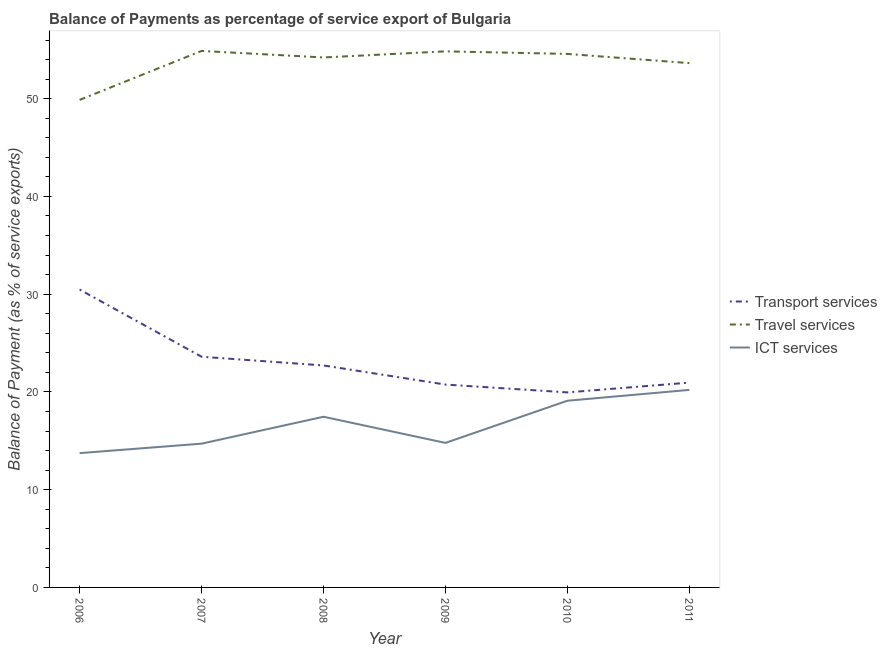Is the number of lines equal to the number of legend labels?
Offer a terse response. Yes. What is the balance of payment of ict services in 2009?
Offer a very short reply. 14.78. Across all years, what is the maximum balance of payment of travel services?
Offer a very short reply. 54.88. Across all years, what is the minimum balance of payment of travel services?
Ensure brevity in your answer.  49.87. In which year was the balance of payment of transport services minimum?
Your response must be concise. 2010. What is the total balance of payment of ict services in the graph?
Provide a succinct answer. 100. What is the difference between the balance of payment of ict services in 2008 and that in 2010?
Your answer should be compact. -1.64. What is the difference between the balance of payment of travel services in 2010 and the balance of payment of transport services in 2011?
Your answer should be compact. 33.62. What is the average balance of payment of ict services per year?
Offer a terse response. 16.67. In the year 2006, what is the difference between the balance of payment of travel services and balance of payment of transport services?
Offer a terse response. 19.4. In how many years, is the balance of payment of travel services greater than 20 %?
Your answer should be very brief. 6. What is the ratio of the balance of payment of transport services in 2007 to that in 2010?
Offer a terse response. 1.18. Is the difference between the balance of payment of transport services in 2006 and 2007 greater than the difference between the balance of payment of travel services in 2006 and 2007?
Your response must be concise. Yes. What is the difference between the highest and the second highest balance of payment of travel services?
Ensure brevity in your answer.  0.04. What is the difference between the highest and the lowest balance of payment of transport services?
Ensure brevity in your answer.  10.52. Does the balance of payment of transport services monotonically increase over the years?
Give a very brief answer. No. Is the balance of payment of travel services strictly less than the balance of payment of ict services over the years?
Your answer should be compact. No. How many lines are there?
Provide a short and direct response. 3. What is the difference between two consecutive major ticks on the Y-axis?
Keep it short and to the point. 10. Are the values on the major ticks of Y-axis written in scientific E-notation?
Your answer should be compact. No. How many legend labels are there?
Offer a terse response. 3. What is the title of the graph?
Your answer should be very brief. Balance of Payments as percentage of service export of Bulgaria. Does "Transport" appear as one of the legend labels in the graph?
Offer a terse response. No. What is the label or title of the X-axis?
Your response must be concise. Year. What is the label or title of the Y-axis?
Offer a terse response. Balance of Payment (as % of service exports). What is the Balance of Payment (as % of service exports) of Transport services in 2006?
Make the answer very short. 30.47. What is the Balance of Payment (as % of service exports) of Travel services in 2006?
Your answer should be very brief. 49.87. What is the Balance of Payment (as % of service exports) in ICT services in 2006?
Provide a succinct answer. 13.74. What is the Balance of Payment (as % of service exports) in Transport services in 2007?
Keep it short and to the point. 23.6. What is the Balance of Payment (as % of service exports) of Travel services in 2007?
Offer a very short reply. 54.88. What is the Balance of Payment (as % of service exports) of ICT services in 2007?
Offer a very short reply. 14.71. What is the Balance of Payment (as % of service exports) in Transport services in 2008?
Provide a succinct answer. 22.71. What is the Balance of Payment (as % of service exports) of Travel services in 2008?
Provide a succinct answer. 54.22. What is the Balance of Payment (as % of service exports) of ICT services in 2008?
Offer a very short reply. 17.46. What is the Balance of Payment (as % of service exports) in Transport services in 2009?
Make the answer very short. 20.75. What is the Balance of Payment (as % of service exports) in Travel services in 2009?
Keep it short and to the point. 54.84. What is the Balance of Payment (as % of service exports) in ICT services in 2009?
Provide a short and direct response. 14.78. What is the Balance of Payment (as % of service exports) in Transport services in 2010?
Provide a succinct answer. 19.95. What is the Balance of Payment (as % of service exports) of Travel services in 2010?
Keep it short and to the point. 54.58. What is the Balance of Payment (as % of service exports) in ICT services in 2010?
Your answer should be very brief. 19.1. What is the Balance of Payment (as % of service exports) of Transport services in 2011?
Offer a terse response. 20.95. What is the Balance of Payment (as % of service exports) of Travel services in 2011?
Provide a short and direct response. 53.64. What is the Balance of Payment (as % of service exports) in ICT services in 2011?
Offer a very short reply. 20.21. Across all years, what is the maximum Balance of Payment (as % of service exports) in Transport services?
Make the answer very short. 30.47. Across all years, what is the maximum Balance of Payment (as % of service exports) of Travel services?
Provide a short and direct response. 54.88. Across all years, what is the maximum Balance of Payment (as % of service exports) of ICT services?
Provide a succinct answer. 20.21. Across all years, what is the minimum Balance of Payment (as % of service exports) in Transport services?
Make the answer very short. 19.95. Across all years, what is the minimum Balance of Payment (as % of service exports) of Travel services?
Your answer should be very brief. 49.87. Across all years, what is the minimum Balance of Payment (as % of service exports) in ICT services?
Your answer should be very brief. 13.74. What is the total Balance of Payment (as % of service exports) in Transport services in the graph?
Give a very brief answer. 138.44. What is the total Balance of Payment (as % of service exports) in Travel services in the graph?
Your answer should be very brief. 322.03. What is the total Balance of Payment (as % of service exports) in ICT services in the graph?
Provide a succinct answer. 100. What is the difference between the Balance of Payment (as % of service exports) in Transport services in 2006 and that in 2007?
Your answer should be compact. 6.87. What is the difference between the Balance of Payment (as % of service exports) in Travel services in 2006 and that in 2007?
Your answer should be very brief. -5.01. What is the difference between the Balance of Payment (as % of service exports) in ICT services in 2006 and that in 2007?
Ensure brevity in your answer.  -0.97. What is the difference between the Balance of Payment (as % of service exports) in Transport services in 2006 and that in 2008?
Your answer should be very brief. 7.77. What is the difference between the Balance of Payment (as % of service exports) of Travel services in 2006 and that in 2008?
Make the answer very short. -4.34. What is the difference between the Balance of Payment (as % of service exports) of ICT services in 2006 and that in 2008?
Provide a succinct answer. -3.72. What is the difference between the Balance of Payment (as % of service exports) in Transport services in 2006 and that in 2009?
Give a very brief answer. 9.72. What is the difference between the Balance of Payment (as % of service exports) of Travel services in 2006 and that in 2009?
Your response must be concise. -4.97. What is the difference between the Balance of Payment (as % of service exports) of ICT services in 2006 and that in 2009?
Provide a succinct answer. -1.05. What is the difference between the Balance of Payment (as % of service exports) in Transport services in 2006 and that in 2010?
Offer a terse response. 10.52. What is the difference between the Balance of Payment (as % of service exports) in Travel services in 2006 and that in 2010?
Your answer should be compact. -4.7. What is the difference between the Balance of Payment (as % of service exports) in ICT services in 2006 and that in 2010?
Provide a succinct answer. -5.36. What is the difference between the Balance of Payment (as % of service exports) in Transport services in 2006 and that in 2011?
Offer a terse response. 9.52. What is the difference between the Balance of Payment (as % of service exports) of Travel services in 2006 and that in 2011?
Your response must be concise. -3.76. What is the difference between the Balance of Payment (as % of service exports) in ICT services in 2006 and that in 2011?
Offer a terse response. -6.47. What is the difference between the Balance of Payment (as % of service exports) of Transport services in 2007 and that in 2008?
Provide a succinct answer. 0.89. What is the difference between the Balance of Payment (as % of service exports) of Travel services in 2007 and that in 2008?
Provide a succinct answer. 0.67. What is the difference between the Balance of Payment (as % of service exports) in ICT services in 2007 and that in 2008?
Keep it short and to the point. -2.75. What is the difference between the Balance of Payment (as % of service exports) in Transport services in 2007 and that in 2009?
Provide a short and direct response. 2.85. What is the difference between the Balance of Payment (as % of service exports) in Travel services in 2007 and that in 2009?
Your answer should be compact. 0.04. What is the difference between the Balance of Payment (as % of service exports) in ICT services in 2007 and that in 2009?
Your answer should be very brief. -0.08. What is the difference between the Balance of Payment (as % of service exports) in Transport services in 2007 and that in 2010?
Your response must be concise. 3.65. What is the difference between the Balance of Payment (as % of service exports) of Travel services in 2007 and that in 2010?
Your answer should be compact. 0.31. What is the difference between the Balance of Payment (as % of service exports) of ICT services in 2007 and that in 2010?
Ensure brevity in your answer.  -4.39. What is the difference between the Balance of Payment (as % of service exports) of Transport services in 2007 and that in 2011?
Provide a succinct answer. 2.65. What is the difference between the Balance of Payment (as % of service exports) of Travel services in 2007 and that in 2011?
Provide a succinct answer. 1.25. What is the difference between the Balance of Payment (as % of service exports) in ICT services in 2007 and that in 2011?
Your response must be concise. -5.5. What is the difference between the Balance of Payment (as % of service exports) of Transport services in 2008 and that in 2009?
Provide a succinct answer. 1.96. What is the difference between the Balance of Payment (as % of service exports) of Travel services in 2008 and that in 2009?
Your answer should be very brief. -0.62. What is the difference between the Balance of Payment (as % of service exports) in ICT services in 2008 and that in 2009?
Your answer should be very brief. 2.67. What is the difference between the Balance of Payment (as % of service exports) of Transport services in 2008 and that in 2010?
Keep it short and to the point. 2.76. What is the difference between the Balance of Payment (as % of service exports) of Travel services in 2008 and that in 2010?
Give a very brief answer. -0.36. What is the difference between the Balance of Payment (as % of service exports) of ICT services in 2008 and that in 2010?
Provide a short and direct response. -1.64. What is the difference between the Balance of Payment (as % of service exports) in Transport services in 2008 and that in 2011?
Offer a very short reply. 1.75. What is the difference between the Balance of Payment (as % of service exports) of Travel services in 2008 and that in 2011?
Provide a short and direct response. 0.58. What is the difference between the Balance of Payment (as % of service exports) in ICT services in 2008 and that in 2011?
Your response must be concise. -2.75. What is the difference between the Balance of Payment (as % of service exports) in Transport services in 2009 and that in 2010?
Keep it short and to the point. 0.8. What is the difference between the Balance of Payment (as % of service exports) in Travel services in 2009 and that in 2010?
Your response must be concise. 0.26. What is the difference between the Balance of Payment (as % of service exports) in ICT services in 2009 and that in 2010?
Your response must be concise. -4.31. What is the difference between the Balance of Payment (as % of service exports) of Transport services in 2009 and that in 2011?
Ensure brevity in your answer.  -0.2. What is the difference between the Balance of Payment (as % of service exports) of Travel services in 2009 and that in 2011?
Provide a short and direct response. 1.2. What is the difference between the Balance of Payment (as % of service exports) of ICT services in 2009 and that in 2011?
Offer a very short reply. -5.42. What is the difference between the Balance of Payment (as % of service exports) of Transport services in 2010 and that in 2011?
Give a very brief answer. -1. What is the difference between the Balance of Payment (as % of service exports) of Travel services in 2010 and that in 2011?
Give a very brief answer. 0.94. What is the difference between the Balance of Payment (as % of service exports) in ICT services in 2010 and that in 2011?
Provide a succinct answer. -1.11. What is the difference between the Balance of Payment (as % of service exports) of Transport services in 2006 and the Balance of Payment (as % of service exports) of Travel services in 2007?
Keep it short and to the point. -24.41. What is the difference between the Balance of Payment (as % of service exports) in Transport services in 2006 and the Balance of Payment (as % of service exports) in ICT services in 2007?
Offer a very short reply. 15.77. What is the difference between the Balance of Payment (as % of service exports) in Travel services in 2006 and the Balance of Payment (as % of service exports) in ICT services in 2007?
Keep it short and to the point. 35.17. What is the difference between the Balance of Payment (as % of service exports) of Transport services in 2006 and the Balance of Payment (as % of service exports) of Travel services in 2008?
Provide a short and direct response. -23.74. What is the difference between the Balance of Payment (as % of service exports) of Transport services in 2006 and the Balance of Payment (as % of service exports) of ICT services in 2008?
Ensure brevity in your answer.  13.01. What is the difference between the Balance of Payment (as % of service exports) of Travel services in 2006 and the Balance of Payment (as % of service exports) of ICT services in 2008?
Provide a short and direct response. 32.41. What is the difference between the Balance of Payment (as % of service exports) of Transport services in 2006 and the Balance of Payment (as % of service exports) of Travel services in 2009?
Your answer should be very brief. -24.37. What is the difference between the Balance of Payment (as % of service exports) of Transport services in 2006 and the Balance of Payment (as % of service exports) of ICT services in 2009?
Keep it short and to the point. 15.69. What is the difference between the Balance of Payment (as % of service exports) in Travel services in 2006 and the Balance of Payment (as % of service exports) in ICT services in 2009?
Provide a short and direct response. 35.09. What is the difference between the Balance of Payment (as % of service exports) of Transport services in 2006 and the Balance of Payment (as % of service exports) of Travel services in 2010?
Make the answer very short. -24.1. What is the difference between the Balance of Payment (as % of service exports) of Transport services in 2006 and the Balance of Payment (as % of service exports) of ICT services in 2010?
Make the answer very short. 11.37. What is the difference between the Balance of Payment (as % of service exports) of Travel services in 2006 and the Balance of Payment (as % of service exports) of ICT services in 2010?
Your response must be concise. 30.77. What is the difference between the Balance of Payment (as % of service exports) in Transport services in 2006 and the Balance of Payment (as % of service exports) in Travel services in 2011?
Your answer should be very brief. -23.16. What is the difference between the Balance of Payment (as % of service exports) in Transport services in 2006 and the Balance of Payment (as % of service exports) in ICT services in 2011?
Your response must be concise. 10.27. What is the difference between the Balance of Payment (as % of service exports) in Travel services in 2006 and the Balance of Payment (as % of service exports) in ICT services in 2011?
Offer a very short reply. 29.67. What is the difference between the Balance of Payment (as % of service exports) in Transport services in 2007 and the Balance of Payment (as % of service exports) in Travel services in 2008?
Offer a terse response. -30.62. What is the difference between the Balance of Payment (as % of service exports) of Transport services in 2007 and the Balance of Payment (as % of service exports) of ICT services in 2008?
Give a very brief answer. 6.14. What is the difference between the Balance of Payment (as % of service exports) in Travel services in 2007 and the Balance of Payment (as % of service exports) in ICT services in 2008?
Your answer should be compact. 37.42. What is the difference between the Balance of Payment (as % of service exports) in Transport services in 2007 and the Balance of Payment (as % of service exports) in Travel services in 2009?
Keep it short and to the point. -31.24. What is the difference between the Balance of Payment (as % of service exports) in Transport services in 2007 and the Balance of Payment (as % of service exports) in ICT services in 2009?
Your response must be concise. 8.81. What is the difference between the Balance of Payment (as % of service exports) in Travel services in 2007 and the Balance of Payment (as % of service exports) in ICT services in 2009?
Provide a succinct answer. 40.1. What is the difference between the Balance of Payment (as % of service exports) in Transport services in 2007 and the Balance of Payment (as % of service exports) in Travel services in 2010?
Keep it short and to the point. -30.98. What is the difference between the Balance of Payment (as % of service exports) of Transport services in 2007 and the Balance of Payment (as % of service exports) of ICT services in 2010?
Give a very brief answer. 4.5. What is the difference between the Balance of Payment (as % of service exports) of Travel services in 2007 and the Balance of Payment (as % of service exports) of ICT services in 2010?
Ensure brevity in your answer.  35.78. What is the difference between the Balance of Payment (as % of service exports) of Transport services in 2007 and the Balance of Payment (as % of service exports) of Travel services in 2011?
Give a very brief answer. -30.04. What is the difference between the Balance of Payment (as % of service exports) of Transport services in 2007 and the Balance of Payment (as % of service exports) of ICT services in 2011?
Offer a terse response. 3.39. What is the difference between the Balance of Payment (as % of service exports) in Travel services in 2007 and the Balance of Payment (as % of service exports) in ICT services in 2011?
Provide a short and direct response. 34.67. What is the difference between the Balance of Payment (as % of service exports) of Transport services in 2008 and the Balance of Payment (as % of service exports) of Travel services in 2009?
Make the answer very short. -32.13. What is the difference between the Balance of Payment (as % of service exports) in Transport services in 2008 and the Balance of Payment (as % of service exports) in ICT services in 2009?
Provide a short and direct response. 7.92. What is the difference between the Balance of Payment (as % of service exports) of Travel services in 2008 and the Balance of Payment (as % of service exports) of ICT services in 2009?
Your answer should be compact. 39.43. What is the difference between the Balance of Payment (as % of service exports) in Transport services in 2008 and the Balance of Payment (as % of service exports) in Travel services in 2010?
Keep it short and to the point. -31.87. What is the difference between the Balance of Payment (as % of service exports) of Transport services in 2008 and the Balance of Payment (as % of service exports) of ICT services in 2010?
Make the answer very short. 3.61. What is the difference between the Balance of Payment (as % of service exports) of Travel services in 2008 and the Balance of Payment (as % of service exports) of ICT services in 2010?
Offer a terse response. 35.12. What is the difference between the Balance of Payment (as % of service exports) in Transport services in 2008 and the Balance of Payment (as % of service exports) in Travel services in 2011?
Ensure brevity in your answer.  -30.93. What is the difference between the Balance of Payment (as % of service exports) in Transport services in 2008 and the Balance of Payment (as % of service exports) in ICT services in 2011?
Your response must be concise. 2.5. What is the difference between the Balance of Payment (as % of service exports) in Travel services in 2008 and the Balance of Payment (as % of service exports) in ICT services in 2011?
Make the answer very short. 34.01. What is the difference between the Balance of Payment (as % of service exports) of Transport services in 2009 and the Balance of Payment (as % of service exports) of Travel services in 2010?
Keep it short and to the point. -33.82. What is the difference between the Balance of Payment (as % of service exports) in Transport services in 2009 and the Balance of Payment (as % of service exports) in ICT services in 2010?
Give a very brief answer. 1.65. What is the difference between the Balance of Payment (as % of service exports) in Travel services in 2009 and the Balance of Payment (as % of service exports) in ICT services in 2010?
Your response must be concise. 35.74. What is the difference between the Balance of Payment (as % of service exports) in Transport services in 2009 and the Balance of Payment (as % of service exports) in Travel services in 2011?
Your answer should be compact. -32.88. What is the difference between the Balance of Payment (as % of service exports) of Transport services in 2009 and the Balance of Payment (as % of service exports) of ICT services in 2011?
Keep it short and to the point. 0.54. What is the difference between the Balance of Payment (as % of service exports) of Travel services in 2009 and the Balance of Payment (as % of service exports) of ICT services in 2011?
Offer a very short reply. 34.63. What is the difference between the Balance of Payment (as % of service exports) in Transport services in 2010 and the Balance of Payment (as % of service exports) in Travel services in 2011?
Your answer should be compact. -33.69. What is the difference between the Balance of Payment (as % of service exports) of Transport services in 2010 and the Balance of Payment (as % of service exports) of ICT services in 2011?
Your answer should be very brief. -0.26. What is the difference between the Balance of Payment (as % of service exports) in Travel services in 2010 and the Balance of Payment (as % of service exports) in ICT services in 2011?
Give a very brief answer. 34.37. What is the average Balance of Payment (as % of service exports) of Transport services per year?
Provide a succinct answer. 23.07. What is the average Balance of Payment (as % of service exports) in Travel services per year?
Your response must be concise. 53.67. What is the average Balance of Payment (as % of service exports) of ICT services per year?
Give a very brief answer. 16.67. In the year 2006, what is the difference between the Balance of Payment (as % of service exports) in Transport services and Balance of Payment (as % of service exports) in Travel services?
Ensure brevity in your answer.  -19.4. In the year 2006, what is the difference between the Balance of Payment (as % of service exports) in Transport services and Balance of Payment (as % of service exports) in ICT services?
Provide a succinct answer. 16.73. In the year 2006, what is the difference between the Balance of Payment (as % of service exports) of Travel services and Balance of Payment (as % of service exports) of ICT services?
Your response must be concise. 36.14. In the year 2007, what is the difference between the Balance of Payment (as % of service exports) in Transport services and Balance of Payment (as % of service exports) in Travel services?
Provide a short and direct response. -31.28. In the year 2007, what is the difference between the Balance of Payment (as % of service exports) in Transport services and Balance of Payment (as % of service exports) in ICT services?
Offer a very short reply. 8.89. In the year 2007, what is the difference between the Balance of Payment (as % of service exports) in Travel services and Balance of Payment (as % of service exports) in ICT services?
Your response must be concise. 40.17. In the year 2008, what is the difference between the Balance of Payment (as % of service exports) of Transport services and Balance of Payment (as % of service exports) of Travel services?
Your answer should be very brief. -31.51. In the year 2008, what is the difference between the Balance of Payment (as % of service exports) of Transport services and Balance of Payment (as % of service exports) of ICT services?
Your answer should be compact. 5.25. In the year 2008, what is the difference between the Balance of Payment (as % of service exports) in Travel services and Balance of Payment (as % of service exports) in ICT services?
Provide a succinct answer. 36.76. In the year 2009, what is the difference between the Balance of Payment (as % of service exports) of Transport services and Balance of Payment (as % of service exports) of Travel services?
Ensure brevity in your answer.  -34.09. In the year 2009, what is the difference between the Balance of Payment (as % of service exports) in Transport services and Balance of Payment (as % of service exports) in ICT services?
Offer a terse response. 5.97. In the year 2009, what is the difference between the Balance of Payment (as % of service exports) in Travel services and Balance of Payment (as % of service exports) in ICT services?
Your answer should be very brief. 40.06. In the year 2010, what is the difference between the Balance of Payment (as % of service exports) in Transport services and Balance of Payment (as % of service exports) in Travel services?
Provide a short and direct response. -34.63. In the year 2010, what is the difference between the Balance of Payment (as % of service exports) in Transport services and Balance of Payment (as % of service exports) in ICT services?
Offer a terse response. 0.85. In the year 2010, what is the difference between the Balance of Payment (as % of service exports) of Travel services and Balance of Payment (as % of service exports) of ICT services?
Make the answer very short. 35.48. In the year 2011, what is the difference between the Balance of Payment (as % of service exports) of Transport services and Balance of Payment (as % of service exports) of Travel services?
Offer a very short reply. -32.68. In the year 2011, what is the difference between the Balance of Payment (as % of service exports) in Transport services and Balance of Payment (as % of service exports) in ICT services?
Provide a short and direct response. 0.75. In the year 2011, what is the difference between the Balance of Payment (as % of service exports) in Travel services and Balance of Payment (as % of service exports) in ICT services?
Your response must be concise. 33.43. What is the ratio of the Balance of Payment (as % of service exports) in Transport services in 2006 to that in 2007?
Make the answer very short. 1.29. What is the ratio of the Balance of Payment (as % of service exports) in Travel services in 2006 to that in 2007?
Your answer should be very brief. 0.91. What is the ratio of the Balance of Payment (as % of service exports) of ICT services in 2006 to that in 2007?
Provide a succinct answer. 0.93. What is the ratio of the Balance of Payment (as % of service exports) of Transport services in 2006 to that in 2008?
Your answer should be compact. 1.34. What is the ratio of the Balance of Payment (as % of service exports) in Travel services in 2006 to that in 2008?
Offer a terse response. 0.92. What is the ratio of the Balance of Payment (as % of service exports) in ICT services in 2006 to that in 2008?
Provide a succinct answer. 0.79. What is the ratio of the Balance of Payment (as % of service exports) in Transport services in 2006 to that in 2009?
Your response must be concise. 1.47. What is the ratio of the Balance of Payment (as % of service exports) in Travel services in 2006 to that in 2009?
Your answer should be compact. 0.91. What is the ratio of the Balance of Payment (as % of service exports) of ICT services in 2006 to that in 2009?
Offer a very short reply. 0.93. What is the ratio of the Balance of Payment (as % of service exports) in Transport services in 2006 to that in 2010?
Offer a very short reply. 1.53. What is the ratio of the Balance of Payment (as % of service exports) of Travel services in 2006 to that in 2010?
Provide a succinct answer. 0.91. What is the ratio of the Balance of Payment (as % of service exports) in ICT services in 2006 to that in 2010?
Your response must be concise. 0.72. What is the ratio of the Balance of Payment (as % of service exports) of Transport services in 2006 to that in 2011?
Give a very brief answer. 1.45. What is the ratio of the Balance of Payment (as % of service exports) in Travel services in 2006 to that in 2011?
Your answer should be very brief. 0.93. What is the ratio of the Balance of Payment (as % of service exports) of ICT services in 2006 to that in 2011?
Your answer should be compact. 0.68. What is the ratio of the Balance of Payment (as % of service exports) in Transport services in 2007 to that in 2008?
Provide a short and direct response. 1.04. What is the ratio of the Balance of Payment (as % of service exports) of Travel services in 2007 to that in 2008?
Provide a succinct answer. 1.01. What is the ratio of the Balance of Payment (as % of service exports) in ICT services in 2007 to that in 2008?
Your response must be concise. 0.84. What is the ratio of the Balance of Payment (as % of service exports) in Transport services in 2007 to that in 2009?
Offer a terse response. 1.14. What is the ratio of the Balance of Payment (as % of service exports) of Travel services in 2007 to that in 2009?
Your answer should be compact. 1. What is the ratio of the Balance of Payment (as % of service exports) of ICT services in 2007 to that in 2009?
Keep it short and to the point. 0.99. What is the ratio of the Balance of Payment (as % of service exports) of Transport services in 2007 to that in 2010?
Provide a short and direct response. 1.18. What is the ratio of the Balance of Payment (as % of service exports) of Travel services in 2007 to that in 2010?
Give a very brief answer. 1.01. What is the ratio of the Balance of Payment (as % of service exports) in ICT services in 2007 to that in 2010?
Offer a very short reply. 0.77. What is the ratio of the Balance of Payment (as % of service exports) in Transport services in 2007 to that in 2011?
Ensure brevity in your answer.  1.13. What is the ratio of the Balance of Payment (as % of service exports) in Travel services in 2007 to that in 2011?
Your answer should be compact. 1.02. What is the ratio of the Balance of Payment (as % of service exports) of ICT services in 2007 to that in 2011?
Keep it short and to the point. 0.73. What is the ratio of the Balance of Payment (as % of service exports) in Transport services in 2008 to that in 2009?
Ensure brevity in your answer.  1.09. What is the ratio of the Balance of Payment (as % of service exports) of Travel services in 2008 to that in 2009?
Offer a terse response. 0.99. What is the ratio of the Balance of Payment (as % of service exports) of ICT services in 2008 to that in 2009?
Make the answer very short. 1.18. What is the ratio of the Balance of Payment (as % of service exports) of Transport services in 2008 to that in 2010?
Offer a very short reply. 1.14. What is the ratio of the Balance of Payment (as % of service exports) of Travel services in 2008 to that in 2010?
Your response must be concise. 0.99. What is the ratio of the Balance of Payment (as % of service exports) in ICT services in 2008 to that in 2010?
Your answer should be very brief. 0.91. What is the ratio of the Balance of Payment (as % of service exports) in Transport services in 2008 to that in 2011?
Your response must be concise. 1.08. What is the ratio of the Balance of Payment (as % of service exports) of Travel services in 2008 to that in 2011?
Your answer should be very brief. 1.01. What is the ratio of the Balance of Payment (as % of service exports) in ICT services in 2008 to that in 2011?
Offer a terse response. 0.86. What is the ratio of the Balance of Payment (as % of service exports) of Transport services in 2009 to that in 2010?
Make the answer very short. 1.04. What is the ratio of the Balance of Payment (as % of service exports) of Travel services in 2009 to that in 2010?
Ensure brevity in your answer.  1. What is the ratio of the Balance of Payment (as % of service exports) of ICT services in 2009 to that in 2010?
Make the answer very short. 0.77. What is the ratio of the Balance of Payment (as % of service exports) of Transport services in 2009 to that in 2011?
Your response must be concise. 0.99. What is the ratio of the Balance of Payment (as % of service exports) in Travel services in 2009 to that in 2011?
Your answer should be very brief. 1.02. What is the ratio of the Balance of Payment (as % of service exports) of ICT services in 2009 to that in 2011?
Your answer should be very brief. 0.73. What is the ratio of the Balance of Payment (as % of service exports) of Transport services in 2010 to that in 2011?
Keep it short and to the point. 0.95. What is the ratio of the Balance of Payment (as % of service exports) in Travel services in 2010 to that in 2011?
Offer a very short reply. 1.02. What is the ratio of the Balance of Payment (as % of service exports) in ICT services in 2010 to that in 2011?
Offer a terse response. 0.95. What is the difference between the highest and the second highest Balance of Payment (as % of service exports) of Transport services?
Give a very brief answer. 6.87. What is the difference between the highest and the second highest Balance of Payment (as % of service exports) in Travel services?
Your response must be concise. 0.04. What is the difference between the highest and the second highest Balance of Payment (as % of service exports) of ICT services?
Ensure brevity in your answer.  1.11. What is the difference between the highest and the lowest Balance of Payment (as % of service exports) in Transport services?
Offer a very short reply. 10.52. What is the difference between the highest and the lowest Balance of Payment (as % of service exports) in Travel services?
Make the answer very short. 5.01. What is the difference between the highest and the lowest Balance of Payment (as % of service exports) of ICT services?
Give a very brief answer. 6.47. 